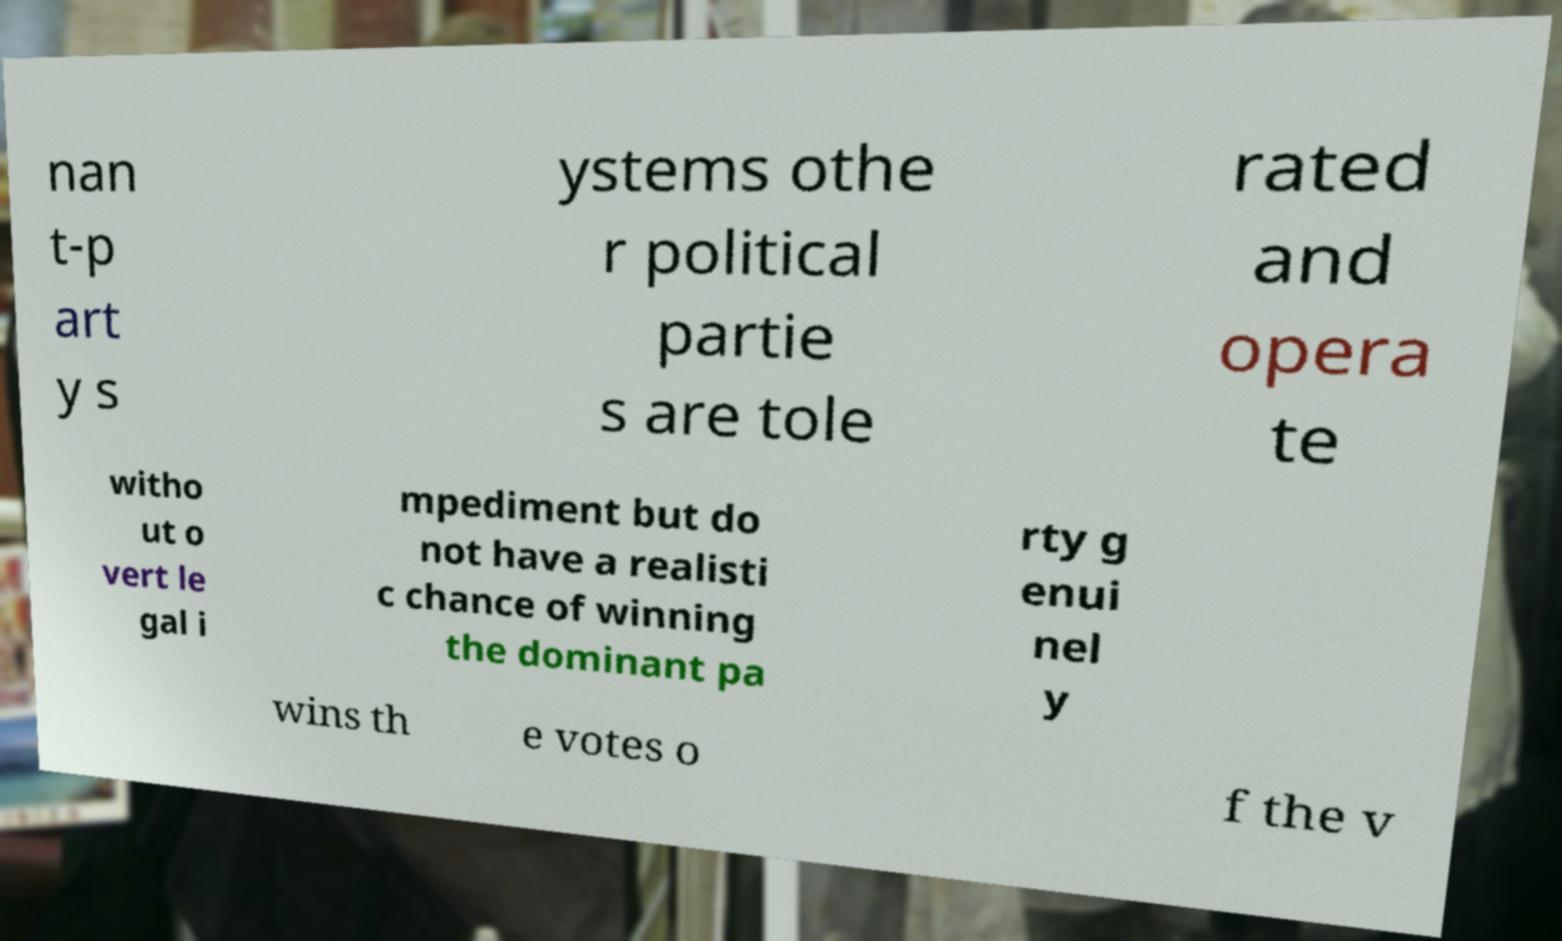What messages or text are displayed in this image? I need them in a readable, typed format. nan t-p art y s ystems othe r political partie s are tole rated and opera te witho ut o vert le gal i mpediment but do not have a realisti c chance of winning the dominant pa rty g enui nel y wins th e votes o f the v 